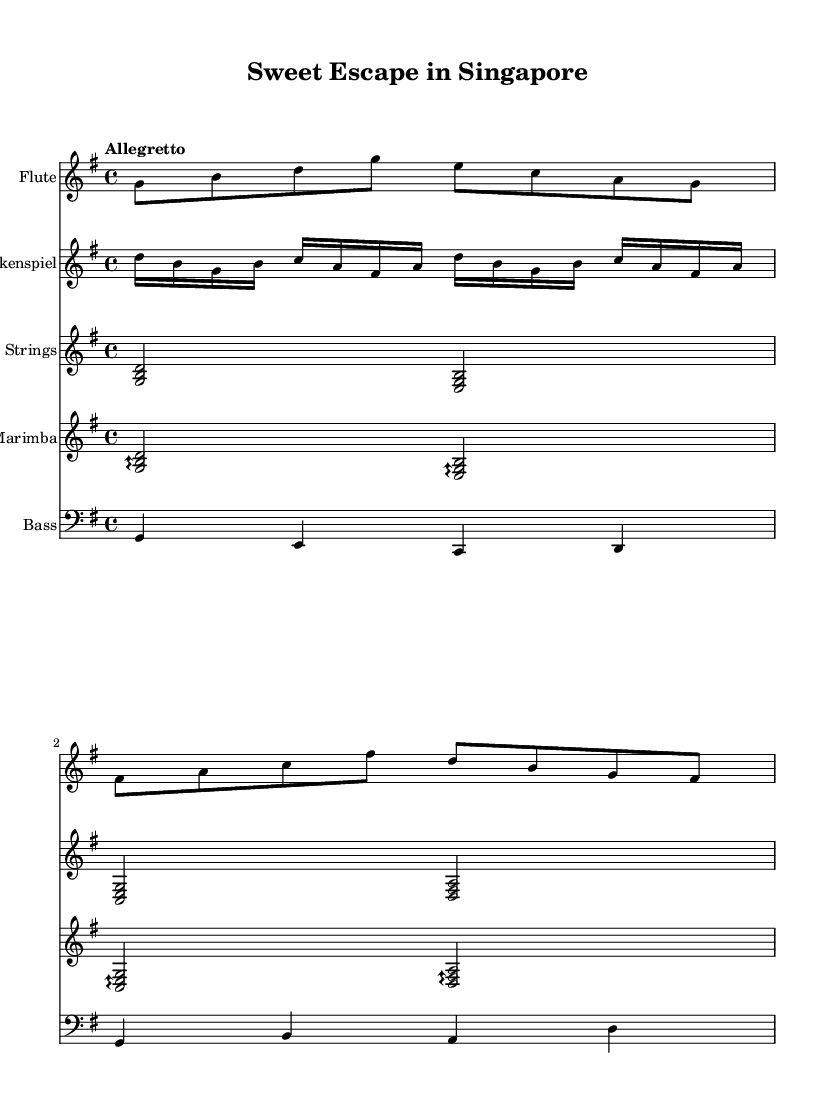What is the key signature of this music? The key signature is G major, which has one sharp (F#). This can be identified by examining the key signature at the beginning of the music staff.
Answer: G major What is the time signature of the piece? The time signature is 4/4, indicated at the beginning of the first measure. This means there are four beats in each measure, and the quarter note gets one beat.
Answer: 4/4 What is the tempo marking of the composition? The tempo marking is "Allegretto." This is the term placed at the beginning, suggesting a moderately fast pace.
Answer: Allegretto How many instruments are in the score? There are five instruments listed, detailed in the score section of the sheet music: Flute, Glockenspiel, Pizzicato Strings, Marimba, and Bass.
Answer: Five Which instrument plays in a higher register? The Glockenspiel plays in a higher register compared to the other instruments. This is evident as it has higher notes throughout the sheet music, typically an octave higher than the Flute.
Answer: Glockenspiel What type of musical piece is this? This piece is a soundtrack, specifically composed for whimsical and playful themes about anthropomorphic desserts and treats, as indicated in the title and the light-hearted instrumentation.
Answer: Soundtrack 